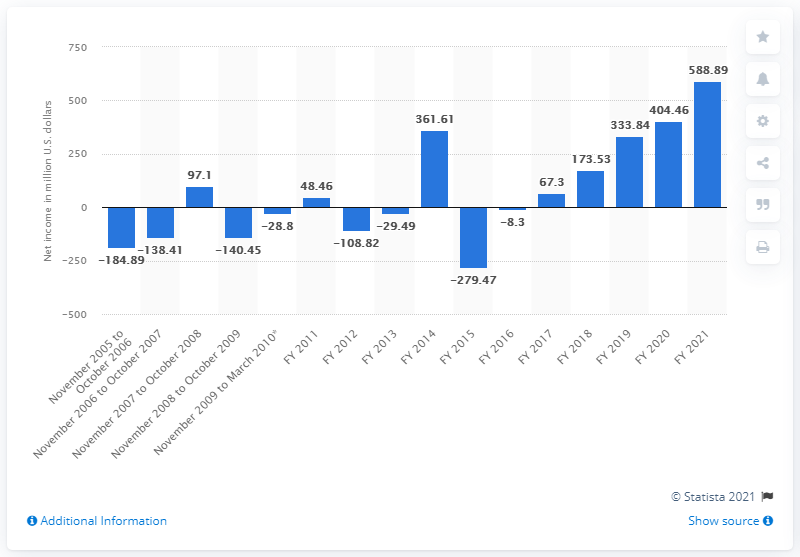What was Take-Two Interactive's net income in 2021? In 2021, Take-Two Interactive reported a net income of $588.89 million, marking its highest earnings recorded within the last decade as depicted in the bar graph from the image. 